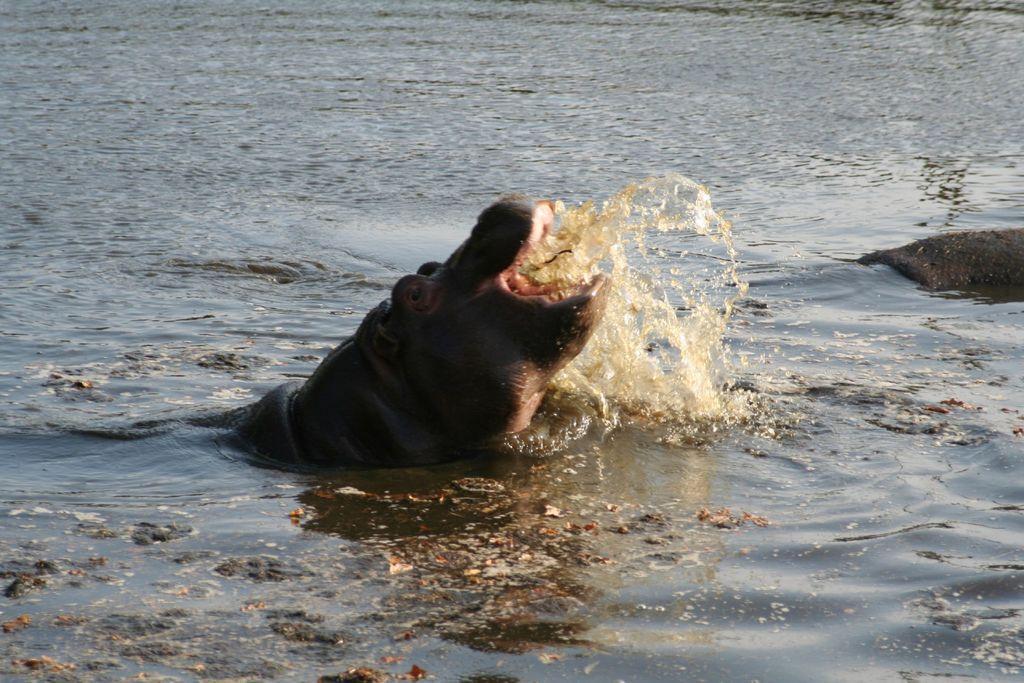In one or two sentences, can you explain what this image depicts? In the image we can see water, in the water there are two hippopotamuses. 